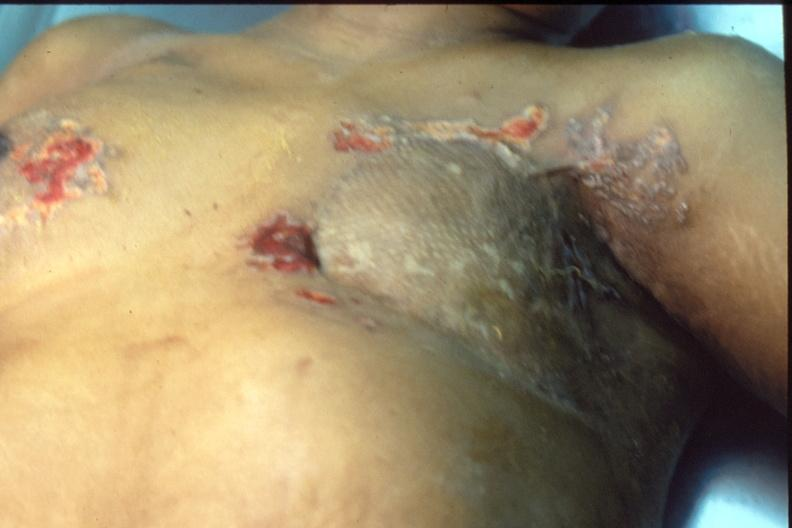does this section show mastectomy scars with skin metastases?
Answer the question using a single word or phrase. No 